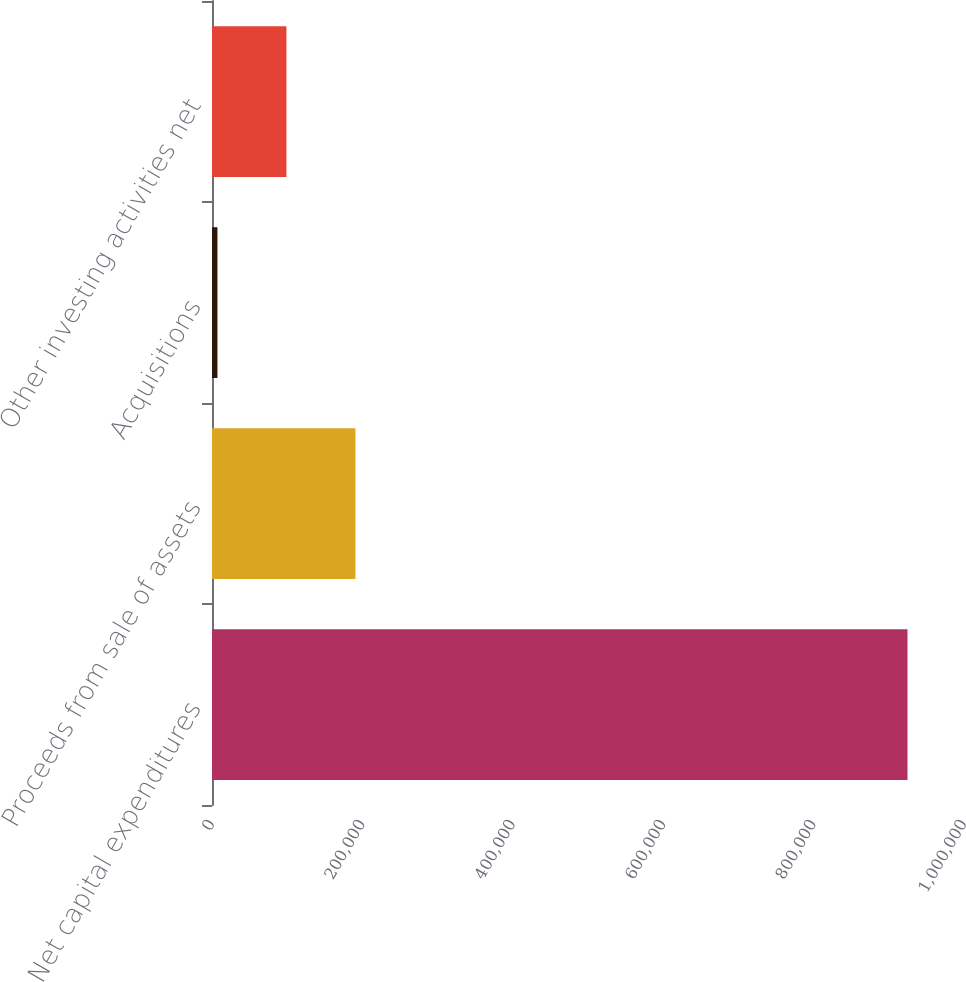Convert chart to OTSL. <chart><loc_0><loc_0><loc_500><loc_500><bar_chart><fcel>Net capital expenditures<fcel>Proceeds from sale of assets<fcel>Acquisitions<fcel>Other investing activities net<nl><fcel>924858<fcel>190748<fcel>7220<fcel>98983.8<nl></chart> 